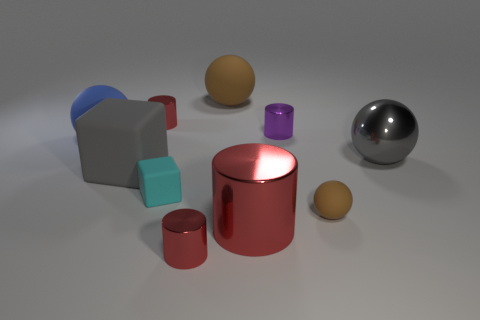Subtract all brown balls. How many red cylinders are left? 3 Subtract all cylinders. How many objects are left? 6 Subtract all brown balls. Subtract all large red metallic things. How many objects are left? 7 Add 3 blue balls. How many blue balls are left? 4 Add 8 tiny brown things. How many tiny brown things exist? 9 Subtract 0 red cubes. How many objects are left? 10 